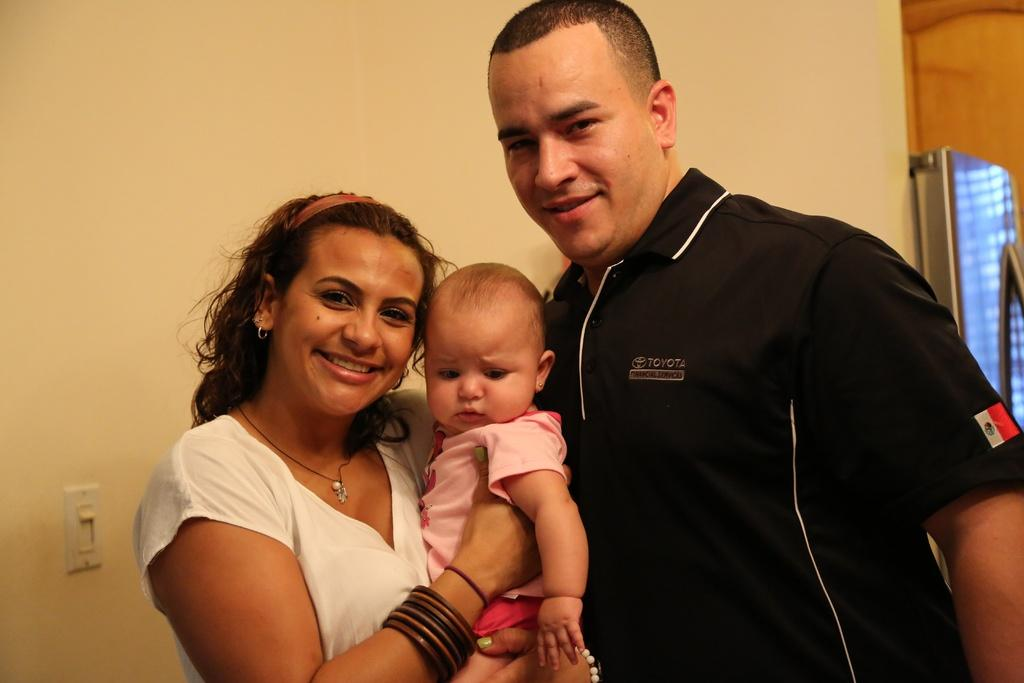<image>
Summarize the visual content of the image. a man in a Toyota uniform with a woman and baby 